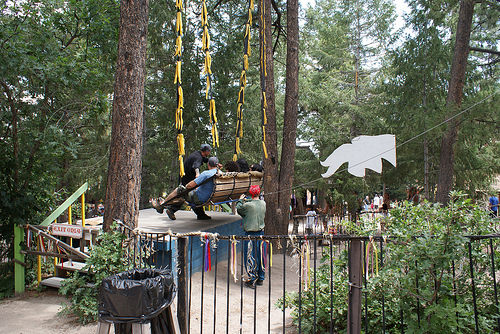<image>
Is the tree behind the waste bin? Yes. From this viewpoint, the tree is positioned behind the waste bin, with the waste bin partially or fully occluding the tree. 